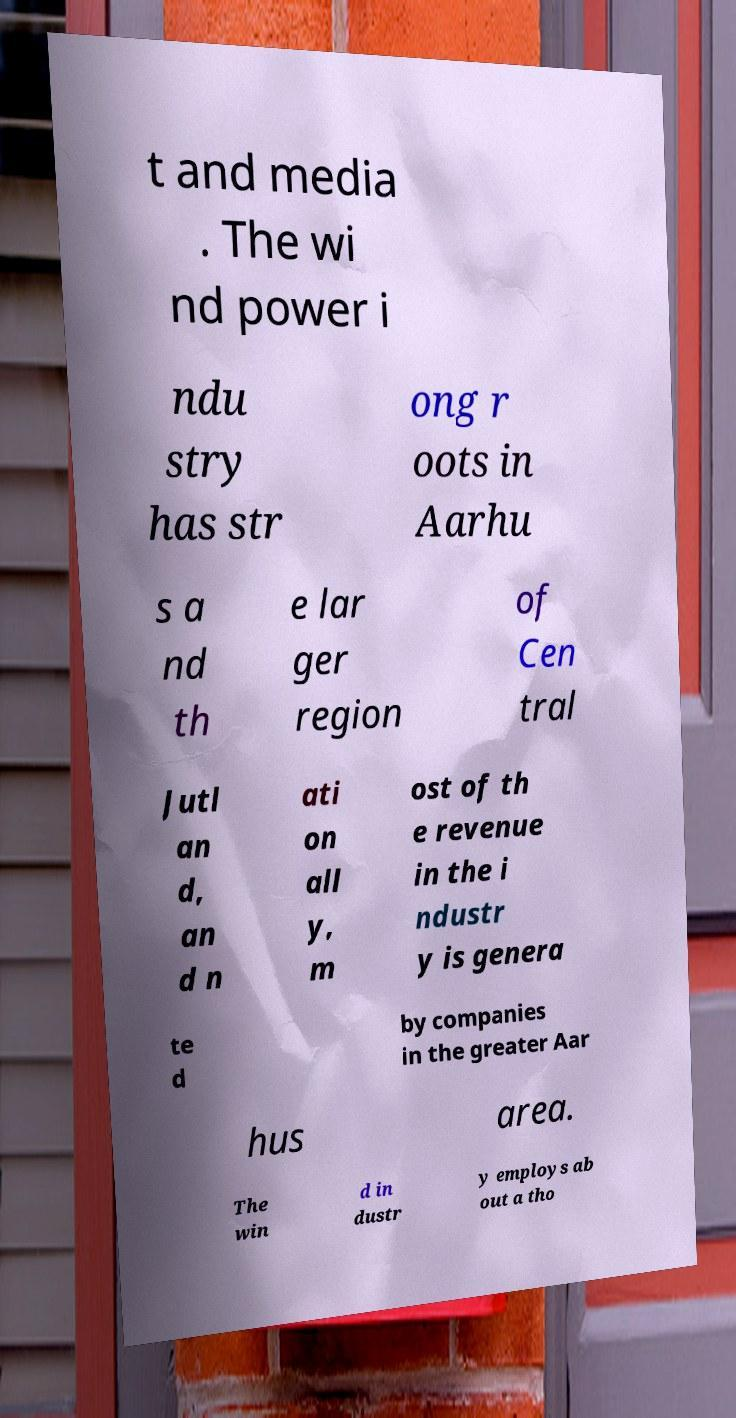There's text embedded in this image that I need extracted. Can you transcribe it verbatim? t and media . The wi nd power i ndu stry has str ong r oots in Aarhu s a nd th e lar ger region of Cen tral Jutl an d, an d n ati on all y, m ost of th e revenue in the i ndustr y is genera te d by companies in the greater Aar hus area. The win d in dustr y employs ab out a tho 